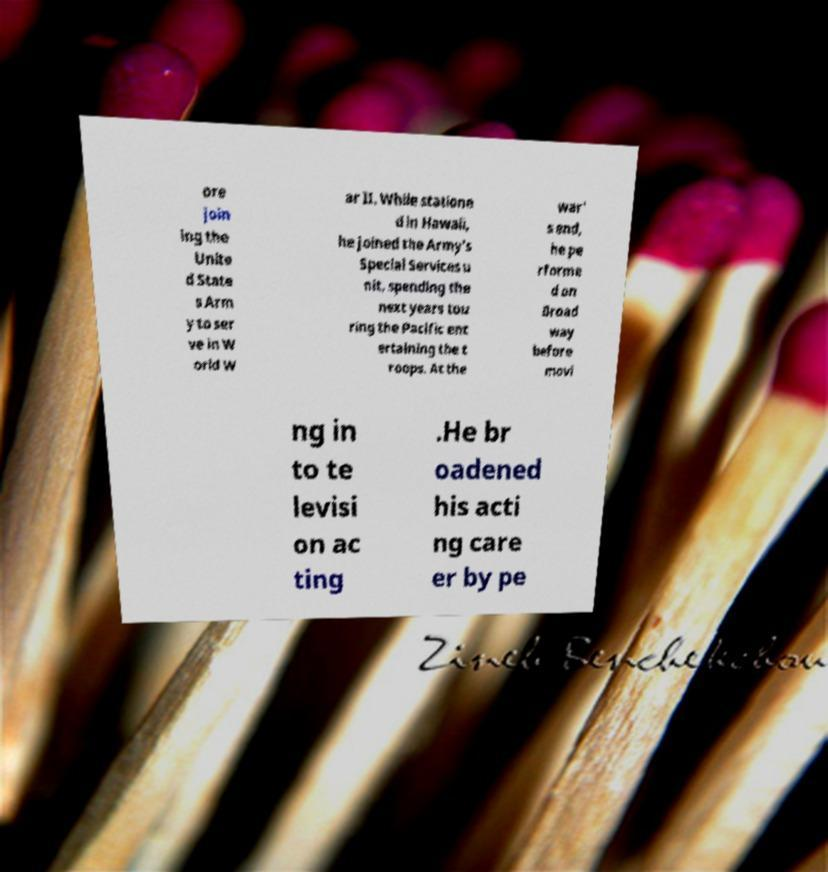I need the written content from this picture converted into text. Can you do that? ore join ing the Unite d State s Arm y to ser ve in W orld W ar II. While statione d in Hawaii, he joined the Army's Special Services u nit, spending the next years tou ring the Pacific ent ertaining the t roops. At the war' s end, he pe rforme d on Broad way before movi ng in to te levisi on ac ting .He br oadened his acti ng care er by pe 